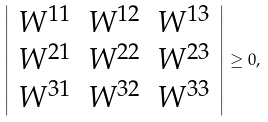Convert formula to latex. <formula><loc_0><loc_0><loc_500><loc_500>\left | \begin{array} { c c c } W ^ { 1 1 } & W ^ { 1 2 } & W ^ { 1 3 } \\ W ^ { 2 1 } & W ^ { 2 2 } & W ^ { 2 3 } \\ W ^ { 3 1 } & W ^ { 3 2 } & W ^ { 3 3 } \end{array} \right | \geq 0 ,</formula> 